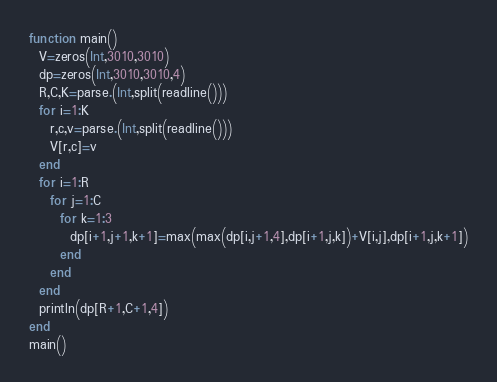Convert code to text. <code><loc_0><loc_0><loc_500><loc_500><_Julia_>function main()
  V=zeros(Int,3010,3010)
  dp=zeros(Int,3010,3010,4)
  R,C,K=parse.(Int,split(readline()))
  for i=1:K
    r,c,v=parse.(Int,split(readline()))
    V[r,c]=v
  end
  for i=1:R
    for j=1:C
      for k=1:3
        dp[i+1,j+1,k+1]=max(max(dp[i,j+1,4],dp[i+1,j,k])+V[i,j],dp[i+1,j,k+1])
      end
    end
  end
  println(dp[R+1,C+1,4])
end
main()</code> 